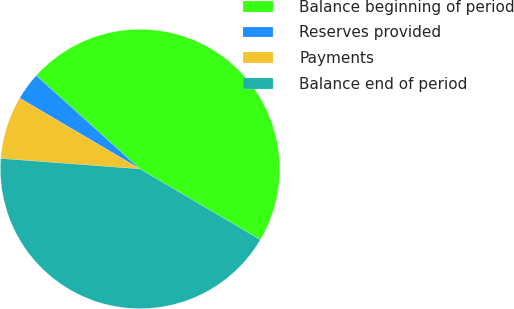Convert chart. <chart><loc_0><loc_0><loc_500><loc_500><pie_chart><fcel>Balance beginning of period<fcel>Reserves provided<fcel>Payments<fcel>Balance end of period<nl><fcel>46.79%<fcel>3.21%<fcel>7.27%<fcel>42.73%<nl></chart> 